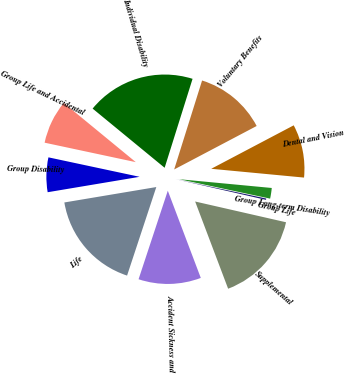Convert chart. <chart><loc_0><loc_0><loc_500><loc_500><pie_chart><fcel>Group Disability<fcel>Group Life and Accidental<fcel>Individual Disability<fcel>Voluntary Benefits<fcel>Dental and Vision<fcel>Group Long-term Disability<fcel>Group Life<fcel>Supplemental<fcel>Accident Sickness and<fcel>Life<nl><fcel>5.99%<fcel>7.6%<fcel>18.89%<fcel>12.44%<fcel>9.22%<fcel>1.84%<fcel>0.23%<fcel>15.67%<fcel>10.83%<fcel>17.28%<nl></chart> 